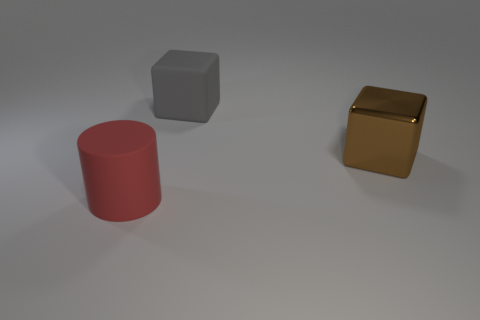Add 3 large green blocks. How many objects exist? 6 Subtract all gray cubes. How many cubes are left? 1 Subtract 1 cubes. How many cubes are left? 1 Subtract all cylinders. How many objects are left? 2 Subtract all blue cylinders. Subtract all yellow cubes. How many cylinders are left? 1 Subtract all green cylinders. How many brown blocks are left? 1 Subtract all large brown metallic cubes. Subtract all large red rubber cylinders. How many objects are left? 1 Add 1 brown metallic objects. How many brown metallic objects are left? 2 Add 3 big gray rubber things. How many big gray rubber things exist? 4 Subtract 0 purple cubes. How many objects are left? 3 